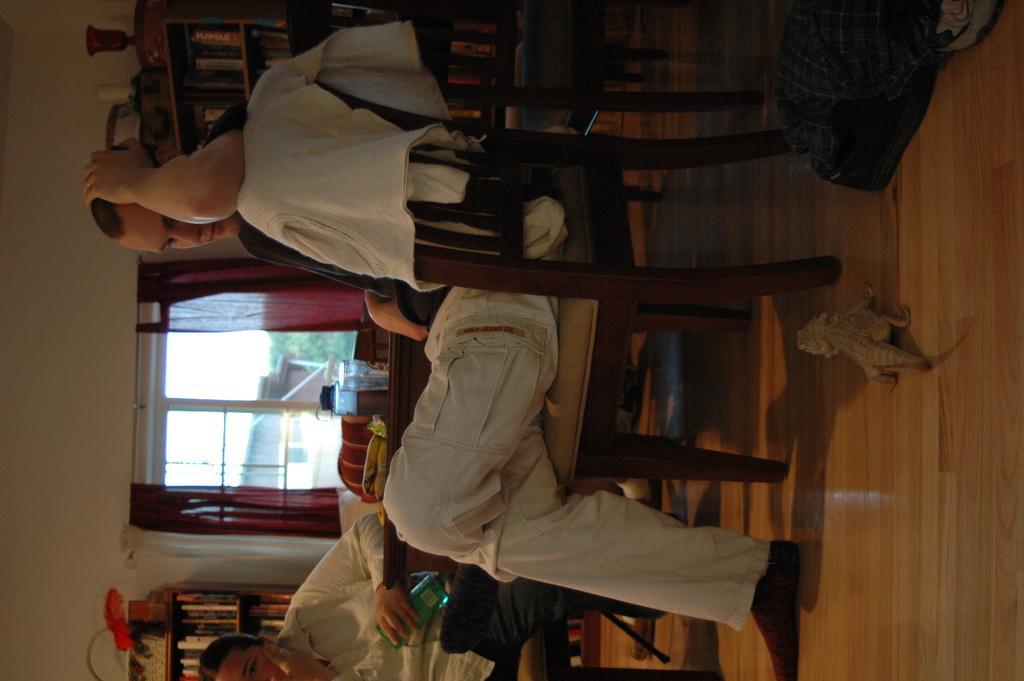Could you give a brief overview of what you see in this image? In this picture I can see a man is sitting on the chair. At the bottom there is another person, on the left side there are windows, on the right side I can see an animal. 